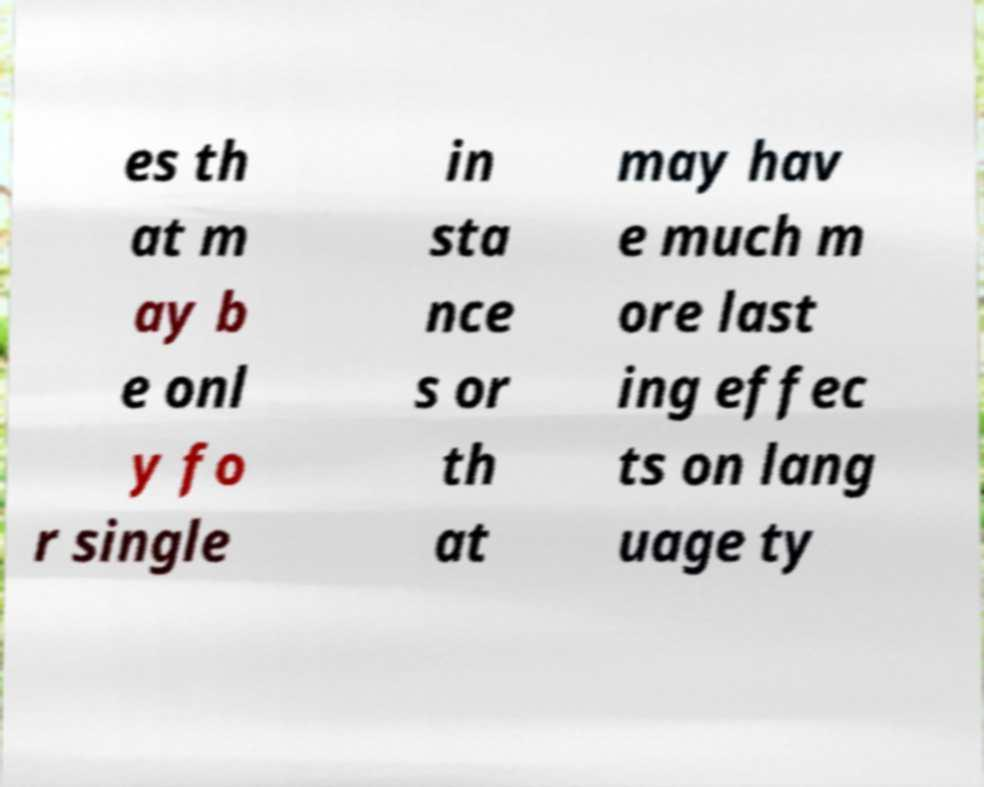Please read and relay the text visible in this image. What does it say? es th at m ay b e onl y fo r single in sta nce s or th at may hav e much m ore last ing effec ts on lang uage ty 